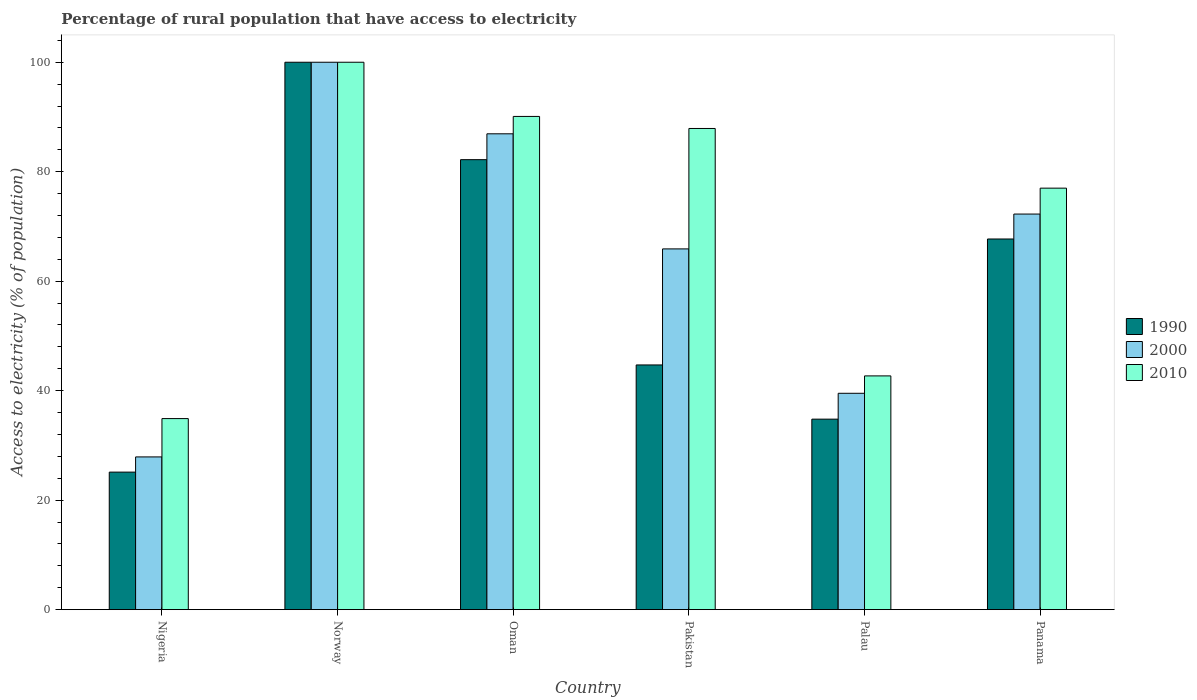How many different coloured bars are there?
Provide a succinct answer. 3. How many groups of bars are there?
Give a very brief answer. 6. Are the number of bars on each tick of the X-axis equal?
Provide a succinct answer. Yes. What is the label of the 4th group of bars from the left?
Your answer should be very brief. Pakistan. What is the percentage of rural population that have access to electricity in 1990 in Palau?
Ensure brevity in your answer.  34.8. Across all countries, what is the maximum percentage of rural population that have access to electricity in 2000?
Your response must be concise. 100. Across all countries, what is the minimum percentage of rural population that have access to electricity in 2000?
Your answer should be very brief. 27.9. In which country was the percentage of rural population that have access to electricity in 1990 minimum?
Your answer should be very brief. Nigeria. What is the total percentage of rural population that have access to electricity in 2000 in the graph?
Provide a short and direct response. 392.51. What is the difference between the percentage of rural population that have access to electricity in 2010 in Nigeria and that in Panama?
Keep it short and to the point. -42.1. What is the difference between the percentage of rural population that have access to electricity in 2000 in Norway and the percentage of rural population that have access to electricity in 2010 in Oman?
Offer a very short reply. 9.9. What is the average percentage of rural population that have access to electricity in 2010 per country?
Your response must be concise. 72.1. What is the difference between the percentage of rural population that have access to electricity of/in 1990 and percentage of rural population that have access to electricity of/in 2010 in Oman?
Offer a terse response. -7.9. What is the ratio of the percentage of rural population that have access to electricity in 2000 in Norway to that in Oman?
Provide a short and direct response. 1.15. Is the percentage of rural population that have access to electricity in 2010 in Norway less than that in Panama?
Offer a very short reply. No. What is the difference between the highest and the second highest percentage of rural population that have access to electricity in 2000?
Your response must be concise. -27.73. What is the difference between the highest and the lowest percentage of rural population that have access to electricity in 2000?
Your response must be concise. 72.1. Is the sum of the percentage of rural population that have access to electricity in 1990 in Palau and Panama greater than the maximum percentage of rural population that have access to electricity in 2000 across all countries?
Offer a very short reply. Yes. What does the 2nd bar from the right in Pakistan represents?
Your response must be concise. 2000. Are all the bars in the graph horizontal?
Offer a very short reply. No. Does the graph contain any zero values?
Your answer should be very brief. No. Does the graph contain grids?
Offer a terse response. No. Where does the legend appear in the graph?
Offer a terse response. Center right. How many legend labels are there?
Provide a succinct answer. 3. How are the legend labels stacked?
Make the answer very short. Vertical. What is the title of the graph?
Make the answer very short. Percentage of rural population that have access to electricity. What is the label or title of the Y-axis?
Provide a succinct answer. Access to electricity (% of population). What is the Access to electricity (% of population) in 1990 in Nigeria?
Your answer should be compact. 25.12. What is the Access to electricity (% of population) in 2000 in Nigeria?
Provide a succinct answer. 27.9. What is the Access to electricity (% of population) of 2010 in Nigeria?
Offer a terse response. 34.9. What is the Access to electricity (% of population) in 1990 in Norway?
Your response must be concise. 100. What is the Access to electricity (% of population) in 1990 in Oman?
Ensure brevity in your answer.  82.2. What is the Access to electricity (% of population) of 2000 in Oman?
Your answer should be very brief. 86.93. What is the Access to electricity (% of population) in 2010 in Oman?
Make the answer very short. 90.1. What is the Access to electricity (% of population) in 1990 in Pakistan?
Provide a short and direct response. 44.7. What is the Access to electricity (% of population) in 2000 in Pakistan?
Offer a terse response. 65.9. What is the Access to electricity (% of population) in 2010 in Pakistan?
Your answer should be very brief. 87.9. What is the Access to electricity (% of population) in 1990 in Palau?
Give a very brief answer. 34.8. What is the Access to electricity (% of population) in 2000 in Palau?
Make the answer very short. 39.52. What is the Access to electricity (% of population) in 2010 in Palau?
Keep it short and to the point. 42.7. What is the Access to electricity (% of population) in 1990 in Panama?
Ensure brevity in your answer.  67.71. What is the Access to electricity (% of population) in 2000 in Panama?
Provide a succinct answer. 72.27. Across all countries, what is the maximum Access to electricity (% of population) of 1990?
Offer a very short reply. 100. Across all countries, what is the minimum Access to electricity (% of population) of 1990?
Offer a very short reply. 25.12. Across all countries, what is the minimum Access to electricity (% of population) in 2000?
Your answer should be very brief. 27.9. Across all countries, what is the minimum Access to electricity (% of population) in 2010?
Provide a short and direct response. 34.9. What is the total Access to electricity (% of population) in 1990 in the graph?
Make the answer very short. 354.53. What is the total Access to electricity (% of population) in 2000 in the graph?
Ensure brevity in your answer.  392.51. What is the total Access to electricity (% of population) of 2010 in the graph?
Provide a short and direct response. 432.6. What is the difference between the Access to electricity (% of population) in 1990 in Nigeria and that in Norway?
Ensure brevity in your answer.  -74.88. What is the difference between the Access to electricity (% of population) in 2000 in Nigeria and that in Norway?
Offer a very short reply. -72.1. What is the difference between the Access to electricity (% of population) of 2010 in Nigeria and that in Norway?
Provide a short and direct response. -65.1. What is the difference between the Access to electricity (% of population) of 1990 in Nigeria and that in Oman?
Your answer should be compact. -57.08. What is the difference between the Access to electricity (% of population) in 2000 in Nigeria and that in Oman?
Offer a terse response. -59.03. What is the difference between the Access to electricity (% of population) in 2010 in Nigeria and that in Oman?
Make the answer very short. -55.2. What is the difference between the Access to electricity (% of population) of 1990 in Nigeria and that in Pakistan?
Your answer should be very brief. -19.58. What is the difference between the Access to electricity (% of population) in 2000 in Nigeria and that in Pakistan?
Your answer should be very brief. -38. What is the difference between the Access to electricity (% of population) of 2010 in Nigeria and that in Pakistan?
Offer a very short reply. -53. What is the difference between the Access to electricity (% of population) of 1990 in Nigeria and that in Palau?
Your answer should be very brief. -9.68. What is the difference between the Access to electricity (% of population) of 2000 in Nigeria and that in Palau?
Offer a terse response. -11.62. What is the difference between the Access to electricity (% of population) of 2010 in Nigeria and that in Palau?
Provide a short and direct response. -7.8. What is the difference between the Access to electricity (% of population) of 1990 in Nigeria and that in Panama?
Give a very brief answer. -42.59. What is the difference between the Access to electricity (% of population) in 2000 in Nigeria and that in Panama?
Make the answer very short. -44.37. What is the difference between the Access to electricity (% of population) of 2010 in Nigeria and that in Panama?
Provide a succinct answer. -42.1. What is the difference between the Access to electricity (% of population) of 1990 in Norway and that in Oman?
Offer a terse response. 17.8. What is the difference between the Access to electricity (% of population) in 2000 in Norway and that in Oman?
Give a very brief answer. 13.07. What is the difference between the Access to electricity (% of population) of 2010 in Norway and that in Oman?
Offer a very short reply. 9.9. What is the difference between the Access to electricity (% of population) of 1990 in Norway and that in Pakistan?
Provide a succinct answer. 55.3. What is the difference between the Access to electricity (% of population) in 2000 in Norway and that in Pakistan?
Offer a terse response. 34.1. What is the difference between the Access to electricity (% of population) in 1990 in Norway and that in Palau?
Give a very brief answer. 65.2. What is the difference between the Access to electricity (% of population) in 2000 in Norway and that in Palau?
Keep it short and to the point. 60.48. What is the difference between the Access to electricity (% of population) of 2010 in Norway and that in Palau?
Provide a short and direct response. 57.3. What is the difference between the Access to electricity (% of population) in 1990 in Norway and that in Panama?
Your response must be concise. 32.29. What is the difference between the Access to electricity (% of population) in 2000 in Norway and that in Panama?
Offer a terse response. 27.73. What is the difference between the Access to electricity (% of population) in 1990 in Oman and that in Pakistan?
Ensure brevity in your answer.  37.5. What is the difference between the Access to electricity (% of population) in 2000 in Oman and that in Pakistan?
Offer a terse response. 21.03. What is the difference between the Access to electricity (% of population) in 2010 in Oman and that in Pakistan?
Provide a short and direct response. 2.2. What is the difference between the Access to electricity (% of population) in 1990 in Oman and that in Palau?
Your answer should be compact. 47.41. What is the difference between the Access to electricity (% of population) in 2000 in Oman and that in Palau?
Your answer should be very brief. 47.41. What is the difference between the Access to electricity (% of population) of 2010 in Oman and that in Palau?
Your answer should be compact. 47.4. What is the difference between the Access to electricity (% of population) of 1990 in Oman and that in Panama?
Provide a short and direct response. 14.49. What is the difference between the Access to electricity (% of population) of 2000 in Oman and that in Panama?
Offer a terse response. 14.66. What is the difference between the Access to electricity (% of population) in 2010 in Oman and that in Panama?
Your answer should be very brief. 13.1. What is the difference between the Access to electricity (% of population) of 1990 in Pakistan and that in Palau?
Your answer should be compact. 9.9. What is the difference between the Access to electricity (% of population) in 2000 in Pakistan and that in Palau?
Your response must be concise. 26.38. What is the difference between the Access to electricity (% of population) of 2010 in Pakistan and that in Palau?
Your answer should be very brief. 45.2. What is the difference between the Access to electricity (% of population) in 1990 in Pakistan and that in Panama?
Provide a short and direct response. -23.01. What is the difference between the Access to electricity (% of population) of 2000 in Pakistan and that in Panama?
Provide a succinct answer. -6.36. What is the difference between the Access to electricity (% of population) of 1990 in Palau and that in Panama?
Make the answer very short. -32.91. What is the difference between the Access to electricity (% of population) in 2000 in Palau and that in Panama?
Provide a succinct answer. -32.74. What is the difference between the Access to electricity (% of population) in 2010 in Palau and that in Panama?
Provide a succinct answer. -34.3. What is the difference between the Access to electricity (% of population) in 1990 in Nigeria and the Access to electricity (% of population) in 2000 in Norway?
Make the answer very short. -74.88. What is the difference between the Access to electricity (% of population) in 1990 in Nigeria and the Access to electricity (% of population) in 2010 in Norway?
Your response must be concise. -74.88. What is the difference between the Access to electricity (% of population) in 2000 in Nigeria and the Access to electricity (% of population) in 2010 in Norway?
Ensure brevity in your answer.  -72.1. What is the difference between the Access to electricity (% of population) in 1990 in Nigeria and the Access to electricity (% of population) in 2000 in Oman?
Your answer should be very brief. -61.81. What is the difference between the Access to electricity (% of population) of 1990 in Nigeria and the Access to electricity (% of population) of 2010 in Oman?
Keep it short and to the point. -64.98. What is the difference between the Access to electricity (% of population) of 2000 in Nigeria and the Access to electricity (% of population) of 2010 in Oman?
Your answer should be very brief. -62.2. What is the difference between the Access to electricity (% of population) of 1990 in Nigeria and the Access to electricity (% of population) of 2000 in Pakistan?
Offer a terse response. -40.78. What is the difference between the Access to electricity (% of population) in 1990 in Nigeria and the Access to electricity (% of population) in 2010 in Pakistan?
Provide a short and direct response. -62.78. What is the difference between the Access to electricity (% of population) of 2000 in Nigeria and the Access to electricity (% of population) of 2010 in Pakistan?
Keep it short and to the point. -60. What is the difference between the Access to electricity (% of population) of 1990 in Nigeria and the Access to electricity (% of population) of 2000 in Palau?
Ensure brevity in your answer.  -14.4. What is the difference between the Access to electricity (% of population) of 1990 in Nigeria and the Access to electricity (% of population) of 2010 in Palau?
Give a very brief answer. -17.58. What is the difference between the Access to electricity (% of population) in 2000 in Nigeria and the Access to electricity (% of population) in 2010 in Palau?
Keep it short and to the point. -14.8. What is the difference between the Access to electricity (% of population) in 1990 in Nigeria and the Access to electricity (% of population) in 2000 in Panama?
Give a very brief answer. -47.15. What is the difference between the Access to electricity (% of population) in 1990 in Nigeria and the Access to electricity (% of population) in 2010 in Panama?
Make the answer very short. -51.88. What is the difference between the Access to electricity (% of population) in 2000 in Nigeria and the Access to electricity (% of population) in 2010 in Panama?
Keep it short and to the point. -49.1. What is the difference between the Access to electricity (% of population) of 1990 in Norway and the Access to electricity (% of population) of 2000 in Oman?
Your response must be concise. 13.07. What is the difference between the Access to electricity (% of population) in 2000 in Norway and the Access to electricity (% of population) in 2010 in Oman?
Keep it short and to the point. 9.9. What is the difference between the Access to electricity (% of population) of 1990 in Norway and the Access to electricity (% of population) of 2000 in Pakistan?
Your answer should be very brief. 34.1. What is the difference between the Access to electricity (% of population) in 2000 in Norway and the Access to electricity (% of population) in 2010 in Pakistan?
Offer a terse response. 12.1. What is the difference between the Access to electricity (% of population) in 1990 in Norway and the Access to electricity (% of population) in 2000 in Palau?
Keep it short and to the point. 60.48. What is the difference between the Access to electricity (% of population) of 1990 in Norway and the Access to electricity (% of population) of 2010 in Palau?
Your answer should be very brief. 57.3. What is the difference between the Access to electricity (% of population) of 2000 in Norway and the Access to electricity (% of population) of 2010 in Palau?
Provide a succinct answer. 57.3. What is the difference between the Access to electricity (% of population) of 1990 in Norway and the Access to electricity (% of population) of 2000 in Panama?
Your answer should be compact. 27.73. What is the difference between the Access to electricity (% of population) in 1990 in Norway and the Access to electricity (% of population) in 2010 in Panama?
Your answer should be very brief. 23. What is the difference between the Access to electricity (% of population) of 2000 in Norway and the Access to electricity (% of population) of 2010 in Panama?
Provide a succinct answer. 23. What is the difference between the Access to electricity (% of population) in 1990 in Oman and the Access to electricity (% of population) in 2000 in Pakistan?
Ensure brevity in your answer.  16.3. What is the difference between the Access to electricity (% of population) of 1990 in Oman and the Access to electricity (% of population) of 2010 in Pakistan?
Your answer should be very brief. -5.7. What is the difference between the Access to electricity (% of population) in 2000 in Oman and the Access to electricity (% of population) in 2010 in Pakistan?
Give a very brief answer. -0.97. What is the difference between the Access to electricity (% of population) in 1990 in Oman and the Access to electricity (% of population) in 2000 in Palau?
Offer a very short reply. 42.68. What is the difference between the Access to electricity (% of population) in 1990 in Oman and the Access to electricity (% of population) in 2010 in Palau?
Offer a terse response. 39.5. What is the difference between the Access to electricity (% of population) of 2000 in Oman and the Access to electricity (% of population) of 2010 in Palau?
Offer a terse response. 44.23. What is the difference between the Access to electricity (% of population) of 1990 in Oman and the Access to electricity (% of population) of 2000 in Panama?
Your answer should be compact. 9.94. What is the difference between the Access to electricity (% of population) of 1990 in Oman and the Access to electricity (% of population) of 2010 in Panama?
Make the answer very short. 5.2. What is the difference between the Access to electricity (% of population) in 2000 in Oman and the Access to electricity (% of population) in 2010 in Panama?
Your answer should be very brief. 9.93. What is the difference between the Access to electricity (% of population) in 1990 in Pakistan and the Access to electricity (% of population) in 2000 in Palau?
Ensure brevity in your answer.  5.18. What is the difference between the Access to electricity (% of population) in 1990 in Pakistan and the Access to electricity (% of population) in 2010 in Palau?
Provide a short and direct response. 2. What is the difference between the Access to electricity (% of population) of 2000 in Pakistan and the Access to electricity (% of population) of 2010 in Palau?
Keep it short and to the point. 23.2. What is the difference between the Access to electricity (% of population) in 1990 in Pakistan and the Access to electricity (% of population) in 2000 in Panama?
Offer a terse response. -27.57. What is the difference between the Access to electricity (% of population) of 1990 in Pakistan and the Access to electricity (% of population) of 2010 in Panama?
Make the answer very short. -32.3. What is the difference between the Access to electricity (% of population) in 2000 in Pakistan and the Access to electricity (% of population) in 2010 in Panama?
Your answer should be compact. -11.1. What is the difference between the Access to electricity (% of population) of 1990 in Palau and the Access to electricity (% of population) of 2000 in Panama?
Offer a very short reply. -37.47. What is the difference between the Access to electricity (% of population) in 1990 in Palau and the Access to electricity (% of population) in 2010 in Panama?
Make the answer very short. -42.2. What is the difference between the Access to electricity (% of population) of 2000 in Palau and the Access to electricity (% of population) of 2010 in Panama?
Keep it short and to the point. -37.48. What is the average Access to electricity (% of population) in 1990 per country?
Offer a very short reply. 59.09. What is the average Access to electricity (% of population) of 2000 per country?
Your response must be concise. 65.42. What is the average Access to electricity (% of population) in 2010 per country?
Your answer should be very brief. 72.1. What is the difference between the Access to electricity (% of population) in 1990 and Access to electricity (% of population) in 2000 in Nigeria?
Give a very brief answer. -2.78. What is the difference between the Access to electricity (% of population) in 1990 and Access to electricity (% of population) in 2010 in Nigeria?
Provide a succinct answer. -9.78. What is the difference between the Access to electricity (% of population) of 2000 and Access to electricity (% of population) of 2010 in Nigeria?
Offer a terse response. -7. What is the difference between the Access to electricity (% of population) of 1990 and Access to electricity (% of population) of 2000 in Norway?
Offer a terse response. 0. What is the difference between the Access to electricity (% of population) of 1990 and Access to electricity (% of population) of 2000 in Oman?
Offer a very short reply. -4.72. What is the difference between the Access to electricity (% of population) of 1990 and Access to electricity (% of population) of 2010 in Oman?
Your response must be concise. -7.9. What is the difference between the Access to electricity (% of population) of 2000 and Access to electricity (% of population) of 2010 in Oman?
Keep it short and to the point. -3.17. What is the difference between the Access to electricity (% of population) in 1990 and Access to electricity (% of population) in 2000 in Pakistan?
Ensure brevity in your answer.  -21.2. What is the difference between the Access to electricity (% of population) in 1990 and Access to electricity (% of population) in 2010 in Pakistan?
Your response must be concise. -43.2. What is the difference between the Access to electricity (% of population) in 2000 and Access to electricity (% of population) in 2010 in Pakistan?
Your answer should be very brief. -22. What is the difference between the Access to electricity (% of population) of 1990 and Access to electricity (% of population) of 2000 in Palau?
Offer a very short reply. -4.72. What is the difference between the Access to electricity (% of population) of 1990 and Access to electricity (% of population) of 2010 in Palau?
Your response must be concise. -7.9. What is the difference between the Access to electricity (% of population) of 2000 and Access to electricity (% of population) of 2010 in Palau?
Provide a succinct answer. -3.18. What is the difference between the Access to electricity (% of population) of 1990 and Access to electricity (% of population) of 2000 in Panama?
Your response must be concise. -4.55. What is the difference between the Access to electricity (% of population) of 1990 and Access to electricity (% of population) of 2010 in Panama?
Offer a terse response. -9.29. What is the difference between the Access to electricity (% of population) in 2000 and Access to electricity (% of population) in 2010 in Panama?
Your answer should be compact. -4.74. What is the ratio of the Access to electricity (% of population) in 1990 in Nigeria to that in Norway?
Give a very brief answer. 0.25. What is the ratio of the Access to electricity (% of population) of 2000 in Nigeria to that in Norway?
Keep it short and to the point. 0.28. What is the ratio of the Access to electricity (% of population) of 2010 in Nigeria to that in Norway?
Ensure brevity in your answer.  0.35. What is the ratio of the Access to electricity (% of population) of 1990 in Nigeria to that in Oman?
Keep it short and to the point. 0.31. What is the ratio of the Access to electricity (% of population) of 2000 in Nigeria to that in Oman?
Your answer should be compact. 0.32. What is the ratio of the Access to electricity (% of population) of 2010 in Nigeria to that in Oman?
Give a very brief answer. 0.39. What is the ratio of the Access to electricity (% of population) of 1990 in Nigeria to that in Pakistan?
Keep it short and to the point. 0.56. What is the ratio of the Access to electricity (% of population) of 2000 in Nigeria to that in Pakistan?
Make the answer very short. 0.42. What is the ratio of the Access to electricity (% of population) of 2010 in Nigeria to that in Pakistan?
Give a very brief answer. 0.4. What is the ratio of the Access to electricity (% of population) of 1990 in Nigeria to that in Palau?
Ensure brevity in your answer.  0.72. What is the ratio of the Access to electricity (% of population) of 2000 in Nigeria to that in Palau?
Provide a succinct answer. 0.71. What is the ratio of the Access to electricity (% of population) of 2010 in Nigeria to that in Palau?
Your answer should be very brief. 0.82. What is the ratio of the Access to electricity (% of population) in 1990 in Nigeria to that in Panama?
Provide a succinct answer. 0.37. What is the ratio of the Access to electricity (% of population) in 2000 in Nigeria to that in Panama?
Provide a short and direct response. 0.39. What is the ratio of the Access to electricity (% of population) in 2010 in Nigeria to that in Panama?
Keep it short and to the point. 0.45. What is the ratio of the Access to electricity (% of population) of 1990 in Norway to that in Oman?
Your answer should be compact. 1.22. What is the ratio of the Access to electricity (% of population) of 2000 in Norway to that in Oman?
Your answer should be very brief. 1.15. What is the ratio of the Access to electricity (% of population) of 2010 in Norway to that in Oman?
Keep it short and to the point. 1.11. What is the ratio of the Access to electricity (% of population) of 1990 in Norway to that in Pakistan?
Offer a terse response. 2.24. What is the ratio of the Access to electricity (% of population) in 2000 in Norway to that in Pakistan?
Your answer should be very brief. 1.52. What is the ratio of the Access to electricity (% of population) in 2010 in Norway to that in Pakistan?
Offer a terse response. 1.14. What is the ratio of the Access to electricity (% of population) of 1990 in Norway to that in Palau?
Your response must be concise. 2.87. What is the ratio of the Access to electricity (% of population) in 2000 in Norway to that in Palau?
Make the answer very short. 2.53. What is the ratio of the Access to electricity (% of population) in 2010 in Norway to that in Palau?
Provide a short and direct response. 2.34. What is the ratio of the Access to electricity (% of population) of 1990 in Norway to that in Panama?
Your answer should be compact. 1.48. What is the ratio of the Access to electricity (% of population) in 2000 in Norway to that in Panama?
Provide a short and direct response. 1.38. What is the ratio of the Access to electricity (% of population) in 2010 in Norway to that in Panama?
Ensure brevity in your answer.  1.3. What is the ratio of the Access to electricity (% of population) of 1990 in Oman to that in Pakistan?
Provide a succinct answer. 1.84. What is the ratio of the Access to electricity (% of population) in 2000 in Oman to that in Pakistan?
Offer a terse response. 1.32. What is the ratio of the Access to electricity (% of population) in 1990 in Oman to that in Palau?
Offer a terse response. 2.36. What is the ratio of the Access to electricity (% of population) in 2000 in Oman to that in Palau?
Ensure brevity in your answer.  2.2. What is the ratio of the Access to electricity (% of population) of 2010 in Oman to that in Palau?
Ensure brevity in your answer.  2.11. What is the ratio of the Access to electricity (% of population) of 1990 in Oman to that in Panama?
Offer a terse response. 1.21. What is the ratio of the Access to electricity (% of population) of 2000 in Oman to that in Panama?
Give a very brief answer. 1.2. What is the ratio of the Access to electricity (% of population) of 2010 in Oman to that in Panama?
Give a very brief answer. 1.17. What is the ratio of the Access to electricity (% of population) of 1990 in Pakistan to that in Palau?
Provide a succinct answer. 1.28. What is the ratio of the Access to electricity (% of population) in 2000 in Pakistan to that in Palau?
Offer a terse response. 1.67. What is the ratio of the Access to electricity (% of population) in 2010 in Pakistan to that in Palau?
Offer a terse response. 2.06. What is the ratio of the Access to electricity (% of population) of 1990 in Pakistan to that in Panama?
Your answer should be very brief. 0.66. What is the ratio of the Access to electricity (% of population) of 2000 in Pakistan to that in Panama?
Provide a short and direct response. 0.91. What is the ratio of the Access to electricity (% of population) of 2010 in Pakistan to that in Panama?
Offer a very short reply. 1.14. What is the ratio of the Access to electricity (% of population) of 1990 in Palau to that in Panama?
Keep it short and to the point. 0.51. What is the ratio of the Access to electricity (% of population) of 2000 in Palau to that in Panama?
Give a very brief answer. 0.55. What is the ratio of the Access to electricity (% of population) of 2010 in Palau to that in Panama?
Offer a terse response. 0.55. What is the difference between the highest and the second highest Access to electricity (% of population) in 1990?
Offer a very short reply. 17.8. What is the difference between the highest and the second highest Access to electricity (% of population) in 2000?
Your response must be concise. 13.07. What is the difference between the highest and the second highest Access to electricity (% of population) in 2010?
Provide a short and direct response. 9.9. What is the difference between the highest and the lowest Access to electricity (% of population) in 1990?
Make the answer very short. 74.88. What is the difference between the highest and the lowest Access to electricity (% of population) in 2000?
Your response must be concise. 72.1. What is the difference between the highest and the lowest Access to electricity (% of population) in 2010?
Your response must be concise. 65.1. 